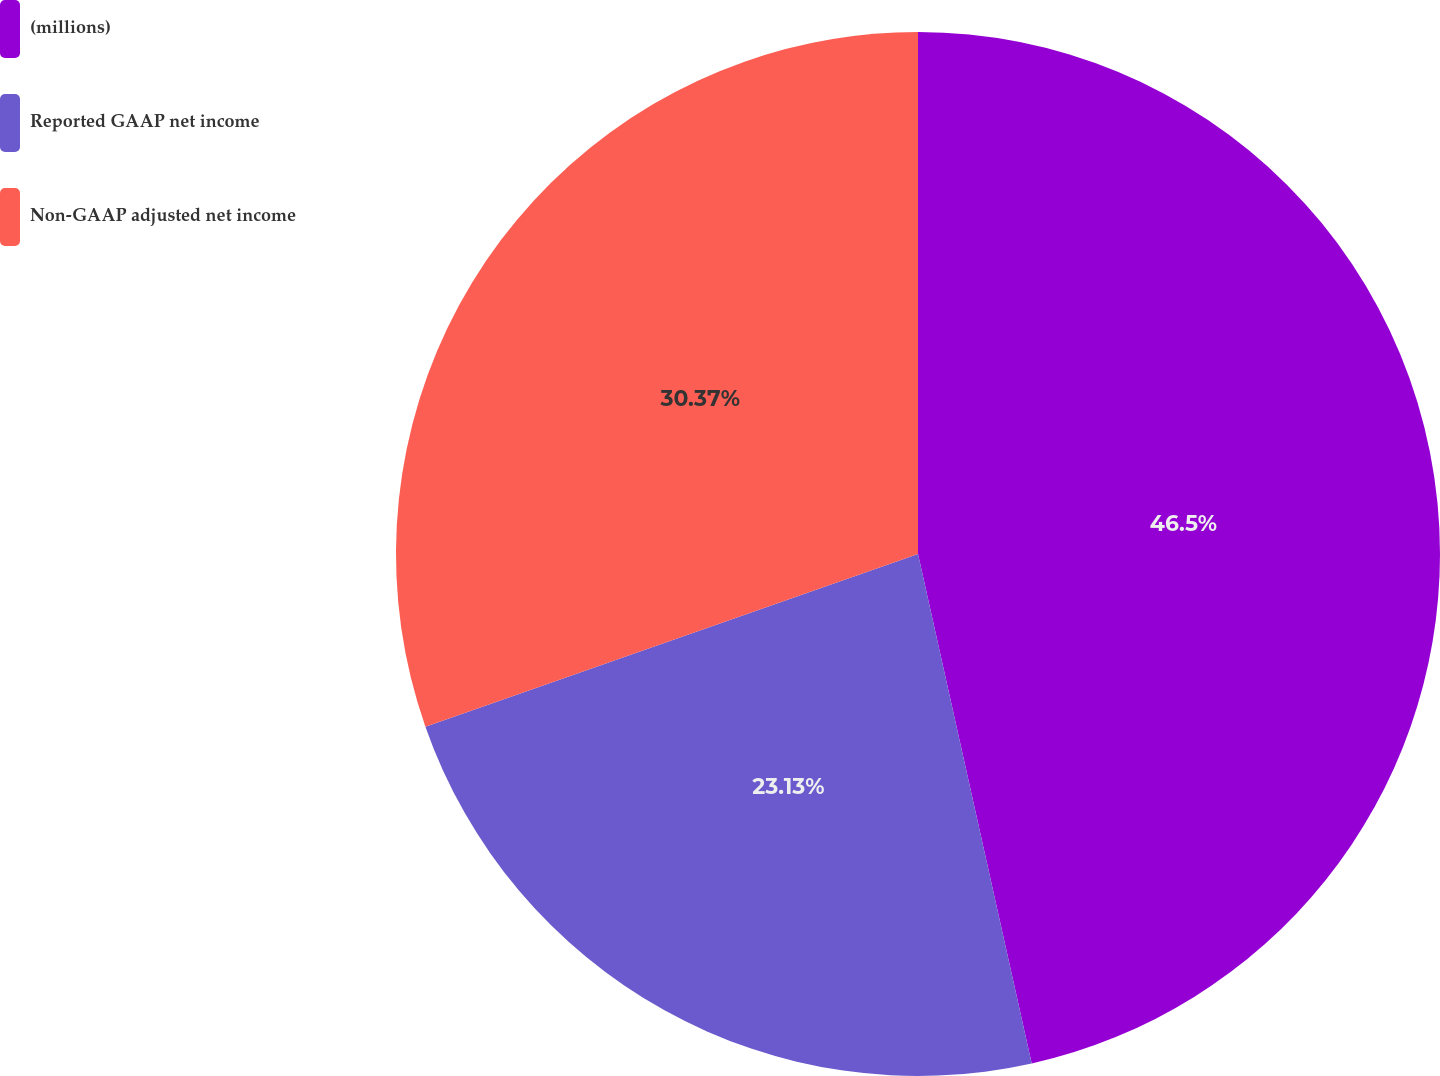<chart> <loc_0><loc_0><loc_500><loc_500><pie_chart><fcel>(millions)<fcel>Reported GAAP net income<fcel>Non-GAAP adjusted net income<nl><fcel>46.51%<fcel>23.13%<fcel>30.37%<nl></chart> 